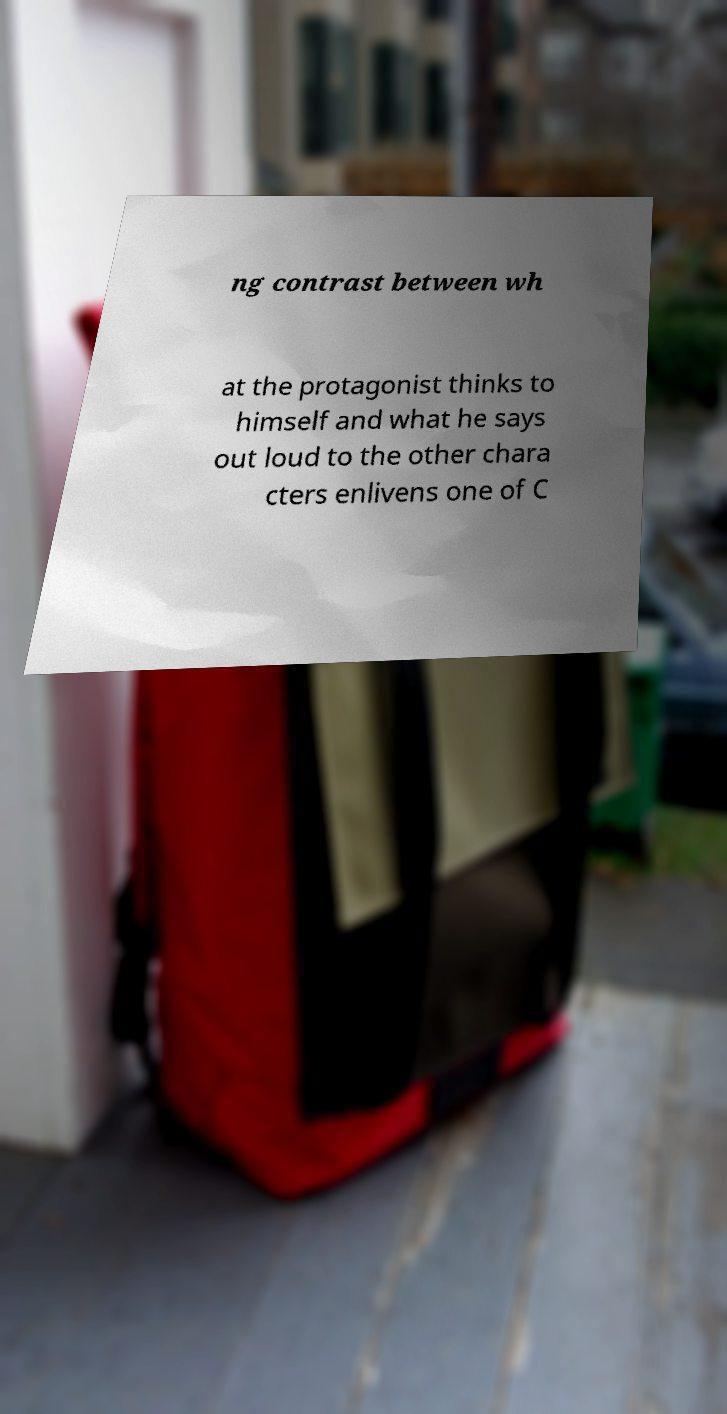Please identify and transcribe the text found in this image. ng contrast between wh at the protagonist thinks to himself and what he says out loud to the other chara cters enlivens one of C 